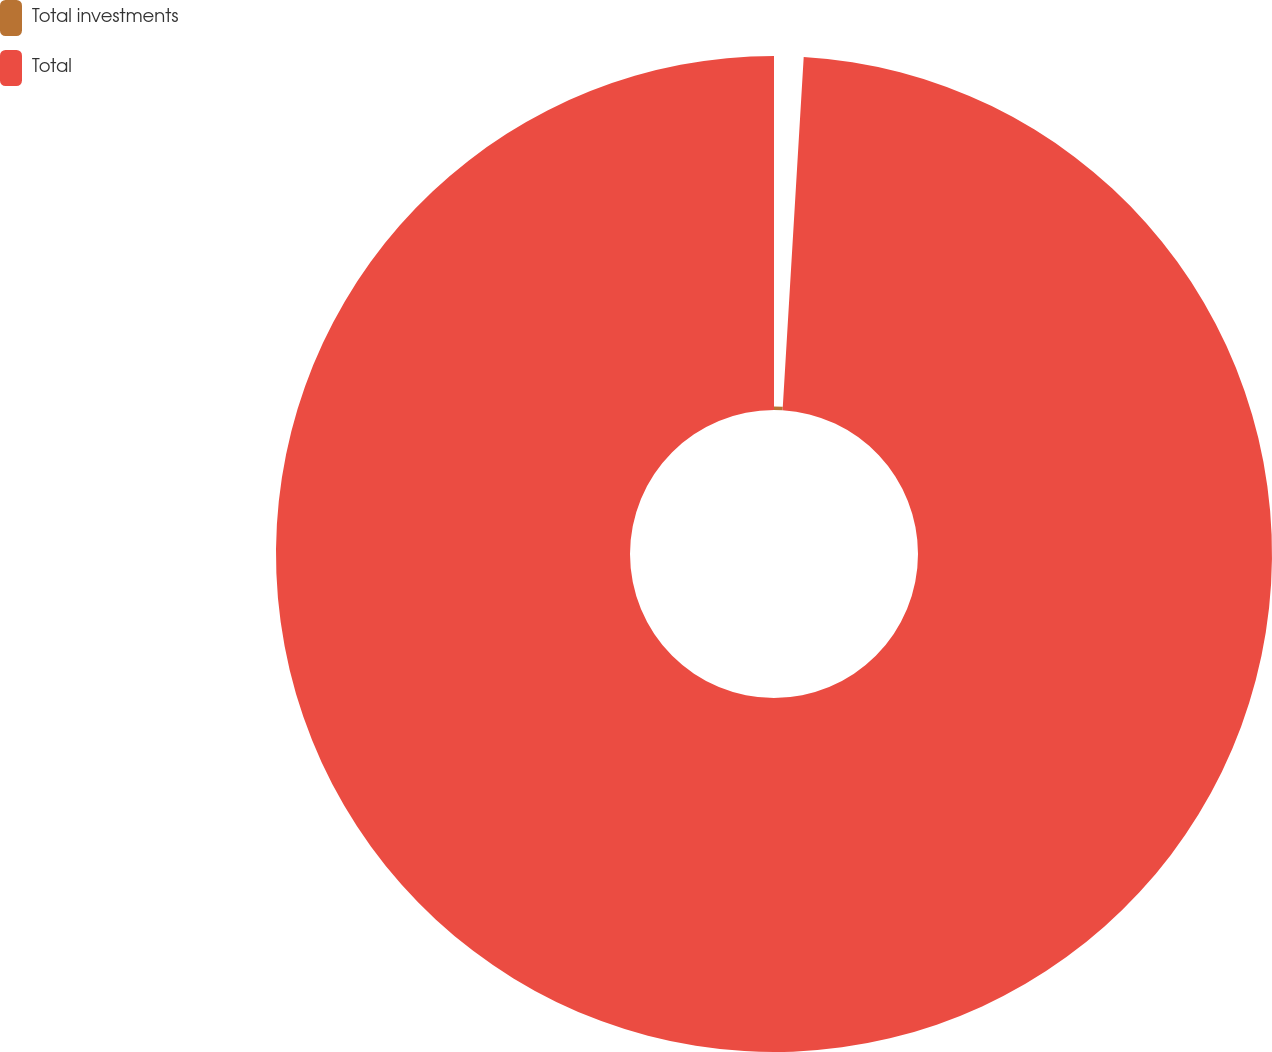Convert chart to OTSL. <chart><loc_0><loc_0><loc_500><loc_500><pie_chart><fcel>Total investments<fcel>Total<nl><fcel>0.95%<fcel>99.05%<nl></chart> 